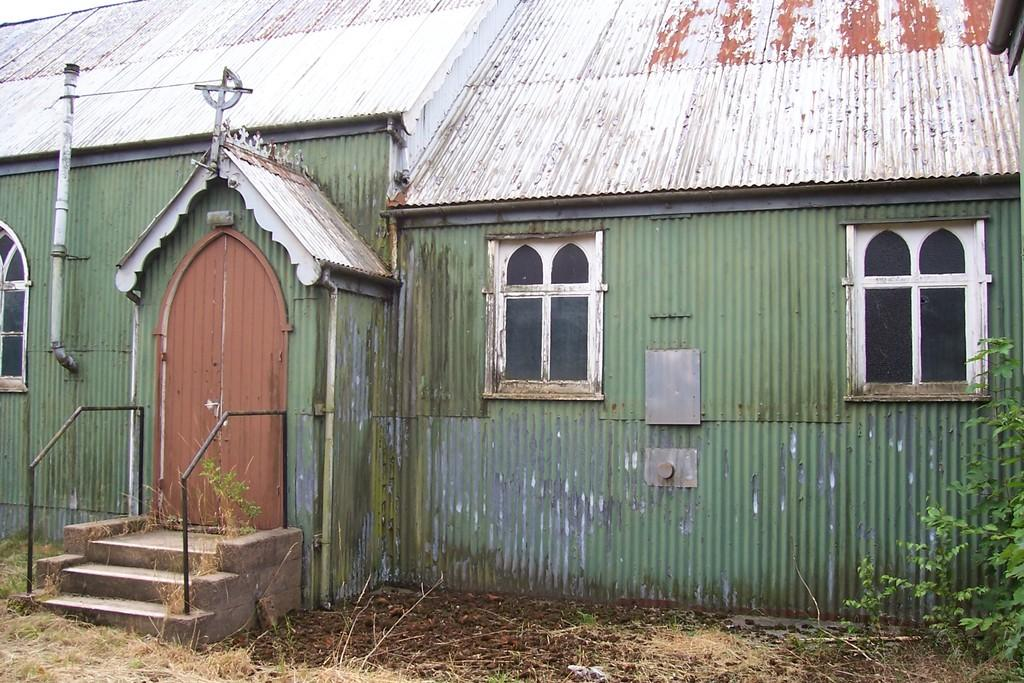What structure can be seen in the image? There is a shed in the image. What feature is located on the left side of the shed? There are stairs on the left side of the shed. What safety feature is present near the stairs? Railings are present near the stairs. What type of vegetation is on the right side of the shed? There is a tree on the right side of the shed. How can someone enter the shed? There is a door on the shed. What allows natural light to enter the shed? There are windows on the shed. What type of badge is the creator wearing in the image? There is no person or badge present in the image; it only features a shed with stairs, railings, a tree, a door, and windows. 